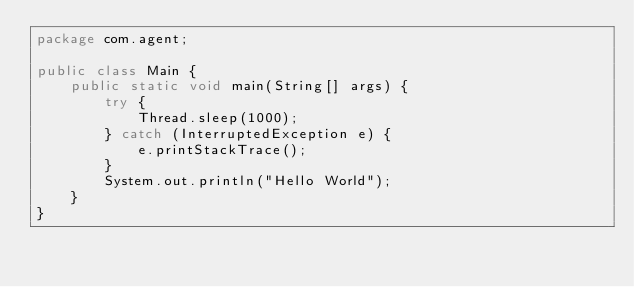Convert code to text. <code><loc_0><loc_0><loc_500><loc_500><_Java_>package com.agent;

public class Main {
    public static void main(String[] args) {
        try {
            Thread.sleep(1000);
        } catch (InterruptedException e) {
            e.printStackTrace();
        }
        System.out.println("Hello World");
    }
}
</code> 